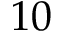Convert formula to latex. <formula><loc_0><loc_0><loc_500><loc_500>1 0</formula> 